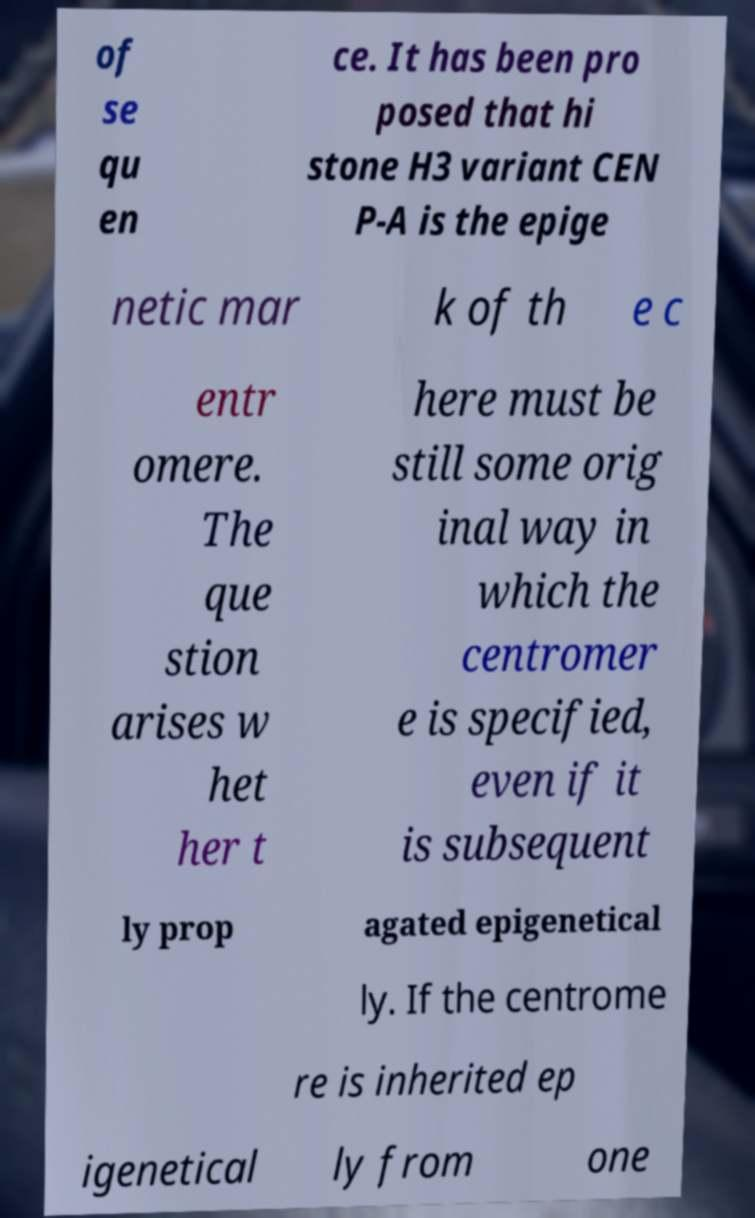There's text embedded in this image that I need extracted. Can you transcribe it verbatim? of se qu en ce. It has been pro posed that hi stone H3 variant CEN P-A is the epige netic mar k of th e c entr omere. The que stion arises w het her t here must be still some orig inal way in which the centromer e is specified, even if it is subsequent ly prop agated epigenetical ly. If the centrome re is inherited ep igenetical ly from one 